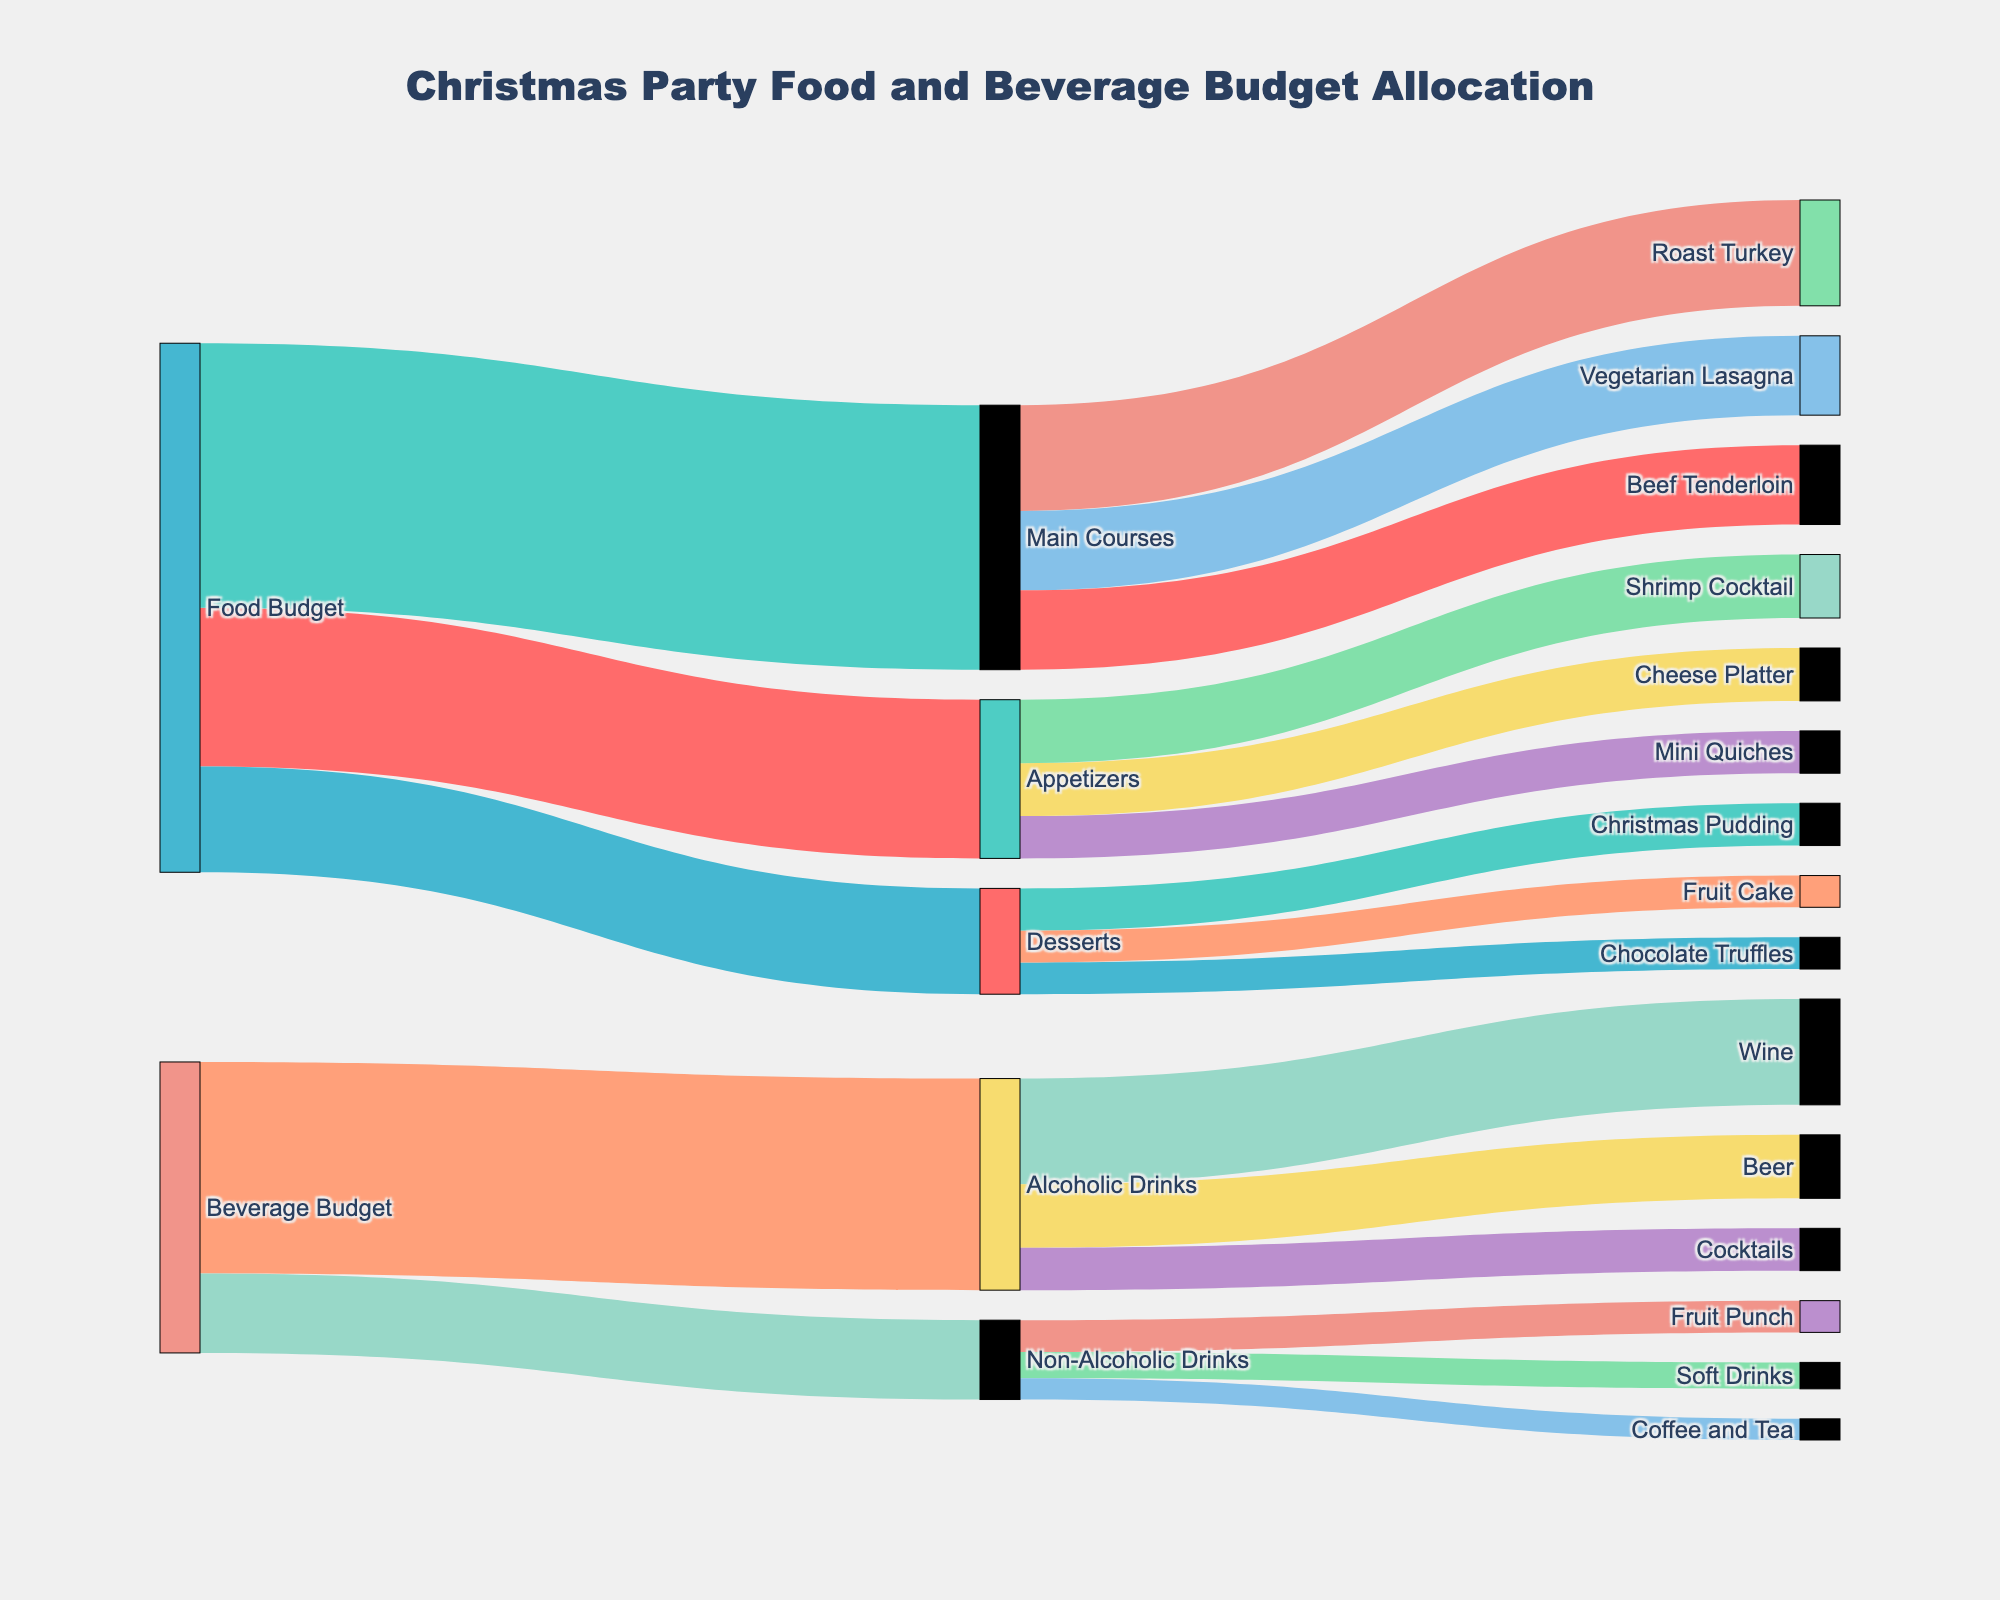What is the maximum amount allocated to a single category within the Beverage Budget? By examining the diagram, we can see that within the Beverage Budget, the categories are Alcoholic Drinks and Non-Alcoholic Drinks. Alcoholic Drinks has the largest allocation with $4000.
Answer: $4000 Which dessert item received the highest allocation? In the Sankey diagram, the dessert items and their allocations are shown under the "Desserts" node. The highest allocation among Christmas Pudding, Chocolate Truffles, and Fruit Cake is Christmas Pudding with $800.
Answer: Christmas Pudding What is the total budget allocated for food items (appetizers, main courses, and desserts)? To find the total budget for food, we sum the amounts allocated to Appetizers, Main Courses, and Desserts. The diagram shows $3000 for Appetizers, $5000 for Main Courses, and $2000 for Desserts. The total is $3000 + $5000 + $2000 = $10000.
Answer: $10000 How does the budget for Wine compare to the budget for Coffee and Tea? From the Sankey diagram, we see that the budget for Wine is $2000, and the budget for Coffee and Tea is $400. Comparing these two amounts, Wine has a higher budget allocation.
Answer: Wine has a higher budget What are the two main course items that received the same budget allocation? By examining the diagram, we observe that Vegetarian Lasagna and Beef Tenderloin both received $1500 each.
Answer: Vegetarian Lasagna and Beef Tenderloin What percentage of the total beverage budget is allocated to Non-Alcoholic Drinks? First, we find the total beverage budget by summing Alcoholic Drinks ($4000) and Non-Alcoholic Drinks ($1500), which is $5500. The Non-Alcoholic Drinks allocation is $1500. To find the percentage: ($1500 / $5500) * 100 = approximately 27.27%.
Answer: 27.27% Which has a larger budget allocation, the sum of all desserts or the total budget for Non-Alcoholic Drinks? The total desserts budget is $2000 (sum of Christmas Pudding, Chocolate Truffles, and Fruit Cake). Non-Alcoholic Drinks total budget is $1500. Comparing these two, the Desserts have a larger allocation of $2000 over Non-Alcoholic Drinks' $1500.
Answer: Desserts have a larger allocation How much more is allocated to Alcoholic Drinks compared to Desserts? The budget for Alcoholic Drinks is $4000, while for Desserts, it is $2000. The difference is $4000 - $2000 = $2000.
Answer: $2000 Which food category has the second highest budget allocation? Reviewing the food categories: Appetizers have $3000, Main Courses have $5000, and Desserts have $2000. The second highest allocation is for Appetizers with $3000.
Answer: Appetizers 